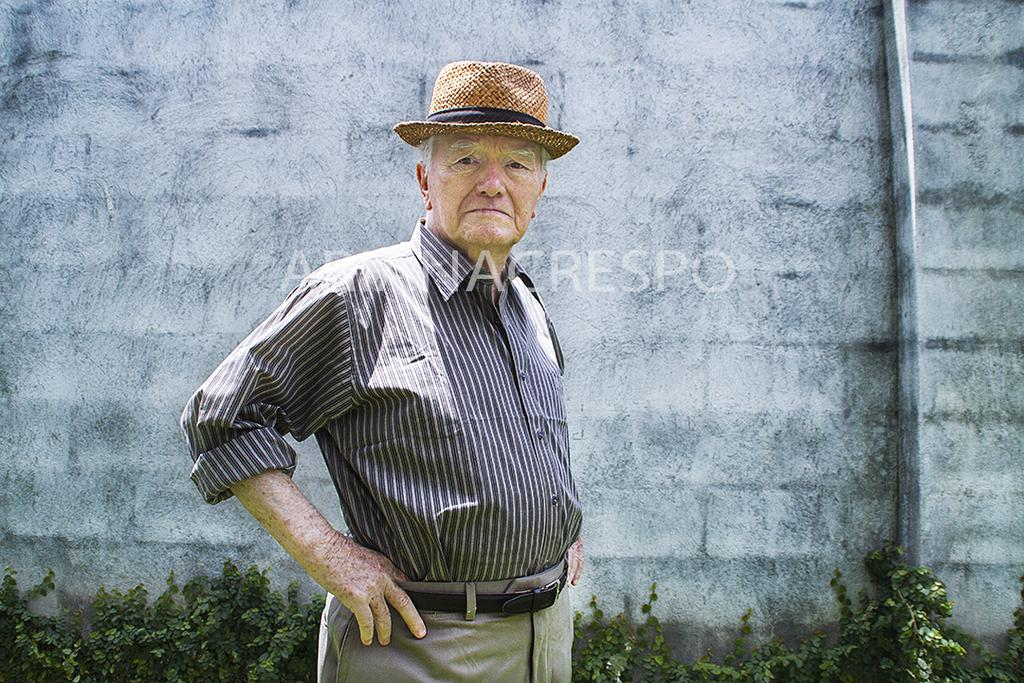Who or what is present in the image? There is a person in the image. What is the person wearing on their head? The person is wearing a hat. Where is the person standing in relation to the wall? The person is standing in front of a wall. What can be seen on the wall in the image? There are plants and a pipe on the wall. What type of sack is being used to transport the industry in the image? There is no sack or industry present in the image. Can you describe the wave pattern on the wall in the image? There is no wave pattern on the wall in the image; it features plants and a pipe. 